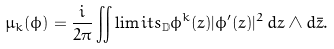Convert formula to latex. <formula><loc_0><loc_0><loc_500><loc_500>\mu _ { k } ( \phi ) = \frac { i } { 2 \pi } \iint \lim i t s _ { \mathbb { D } } \phi ^ { k } ( z ) | \phi ^ { \prime } ( z ) | ^ { 2 } \, d z \wedge d \bar { z } .</formula> 